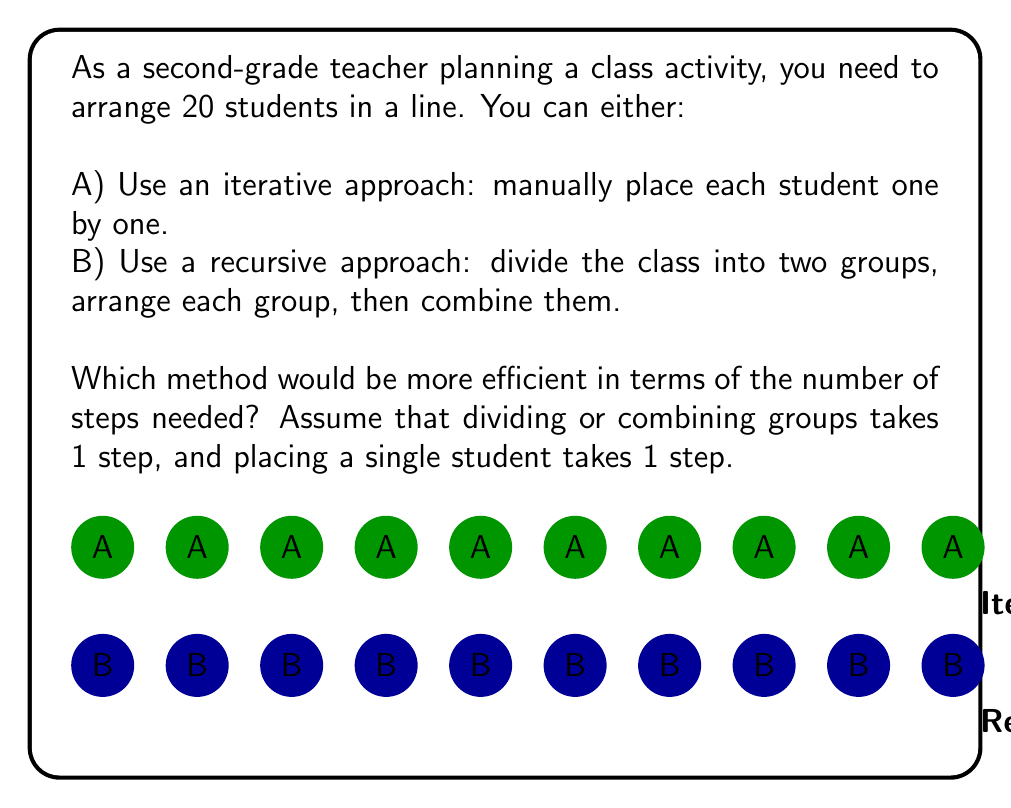What is the answer to this math problem? Let's analyze both approaches:

A) Iterative approach:
   - Each student placement takes 1 step
   - Total steps = $20$ (one for each student)

B) Recursive approach:
   1. Divide the class into two groups of 10 (1 step)
   2. For each group of 10:
      a. Divide into two groups of 5 (1 step)
      b. For each group of 5:
         i. Divide into groups of 2 and 3 (1 step)
         ii. Arrange groups of 2 and 3 (5 steps)
         iii. Combine groups (1 step)
      c. Combine groups of 5 (1 step)
   3. Combine the two groups of 10 (1 step)

   Let's count the steps:
   - Initial division: 1
   - For each group of 10: 1 (divide) + 2 * (1 + 5 + 1) + 1 (combine) = 15
   - Final combination: 1
   
   Total steps = $1 + 2 * 15 + 1 = 32$

The iterative approach (A) requires 20 steps, while the recursive approach (B) requires 32 steps.

Therefore, the iterative approach is more efficient for this problem size.
Answer: Iterative approach (20 steps) 